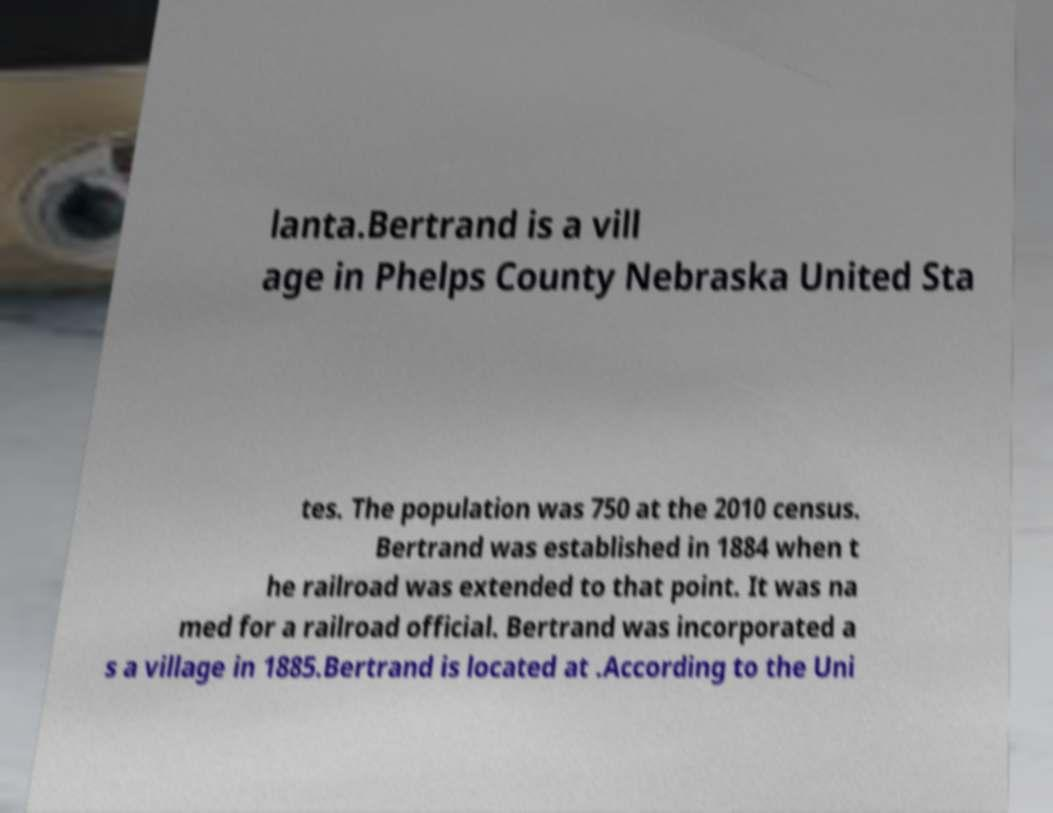Can you accurately transcribe the text from the provided image for me? lanta.Bertrand is a vill age in Phelps County Nebraska United Sta tes. The population was 750 at the 2010 census. Bertrand was established in 1884 when t he railroad was extended to that point. It was na med for a railroad official. Bertrand was incorporated a s a village in 1885.Bertrand is located at .According to the Uni 